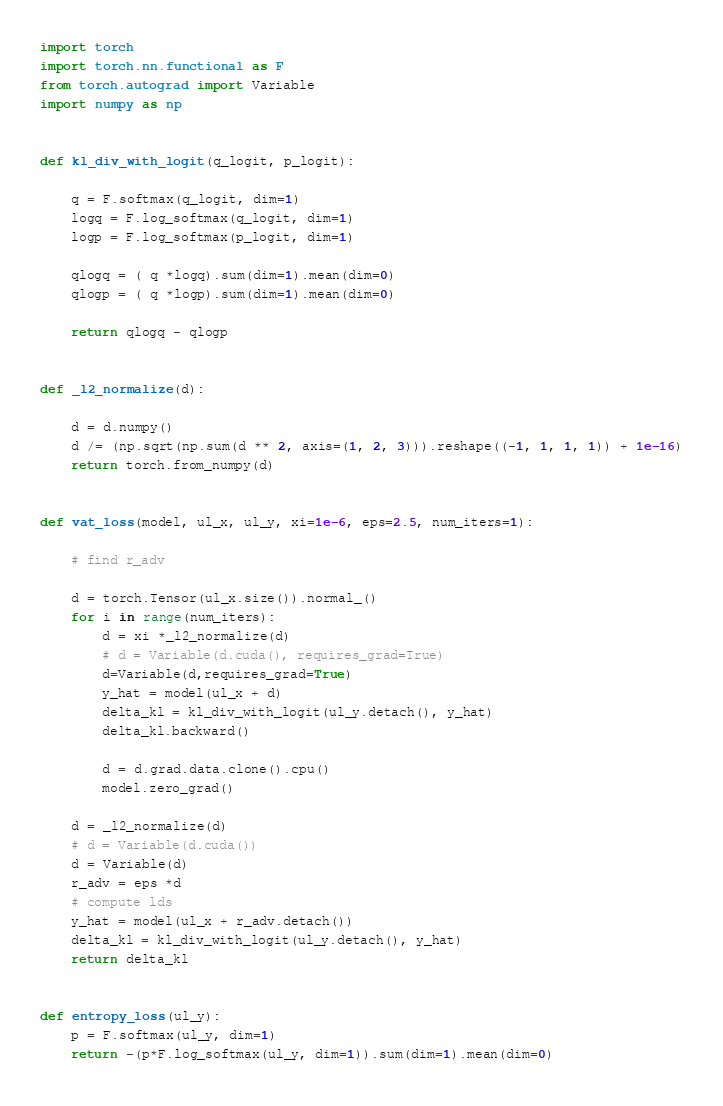Convert code to text. <code><loc_0><loc_0><loc_500><loc_500><_Python_>import torch
import torch.nn.functional as F
from torch.autograd import Variable
import numpy as np


def kl_div_with_logit(q_logit, p_logit):

    q = F.softmax(q_logit, dim=1)
    logq = F.log_softmax(q_logit, dim=1)
    logp = F.log_softmax(p_logit, dim=1)

    qlogq = ( q *logq).sum(dim=1).mean(dim=0)
    qlogp = ( q *logp).sum(dim=1).mean(dim=0)

    return qlogq - qlogp


def _l2_normalize(d):

    d = d.numpy()
    d /= (np.sqrt(np.sum(d ** 2, axis=(1, 2, 3))).reshape((-1, 1, 1, 1)) + 1e-16)
    return torch.from_numpy(d)


def vat_loss(model, ul_x, ul_y, xi=1e-6, eps=2.5, num_iters=1):

    # find r_adv

    d = torch.Tensor(ul_x.size()).normal_()
    for i in range(num_iters):
        d = xi *_l2_normalize(d)
        # d = Variable(d.cuda(), requires_grad=True)
        d=Variable(d,requires_grad=True)
        y_hat = model(ul_x + d)
        delta_kl = kl_div_with_logit(ul_y.detach(), y_hat)
        delta_kl.backward()

        d = d.grad.data.clone().cpu()
        model.zero_grad()

    d = _l2_normalize(d)
    # d = Variable(d.cuda())
    d = Variable(d)
    r_adv = eps *d
    # compute lds
    y_hat = model(ul_x + r_adv.detach())
    delta_kl = kl_div_with_logit(ul_y.detach(), y_hat)
    return delta_kl


def entropy_loss(ul_y):
    p = F.softmax(ul_y, dim=1)
    return -(p*F.log_softmax(ul_y, dim=1)).sum(dim=1).mean(dim=0)</code> 